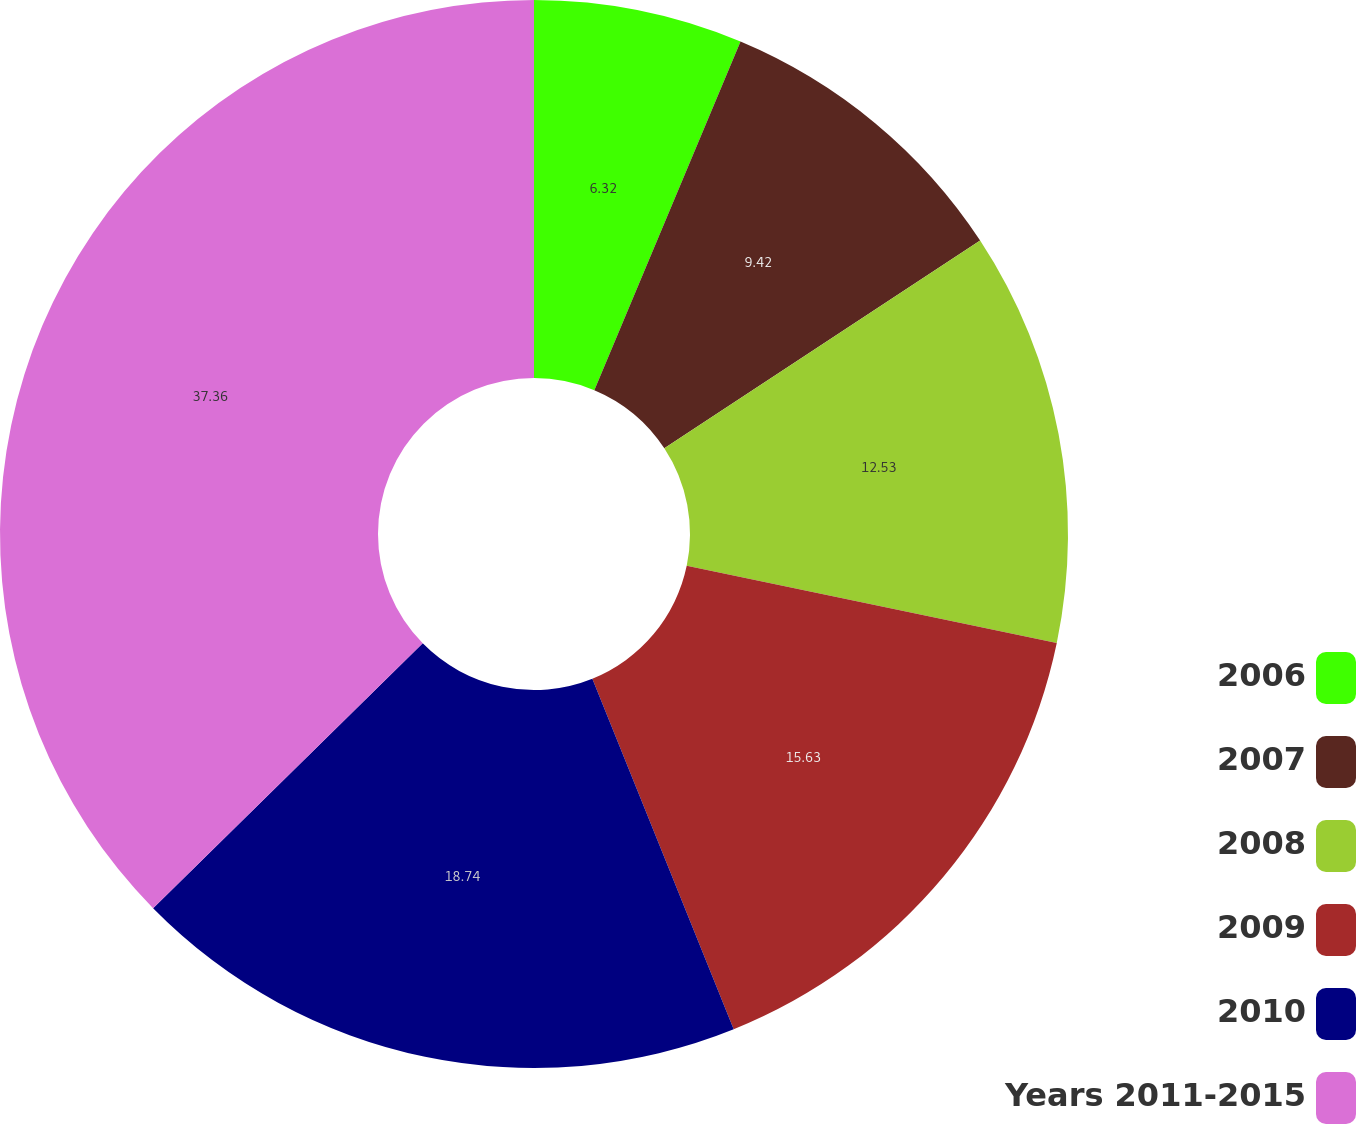Convert chart. <chart><loc_0><loc_0><loc_500><loc_500><pie_chart><fcel>2006<fcel>2007<fcel>2008<fcel>2009<fcel>2010<fcel>Years 2011-2015<nl><fcel>6.32%<fcel>9.42%<fcel>12.53%<fcel>15.63%<fcel>18.74%<fcel>37.36%<nl></chart> 